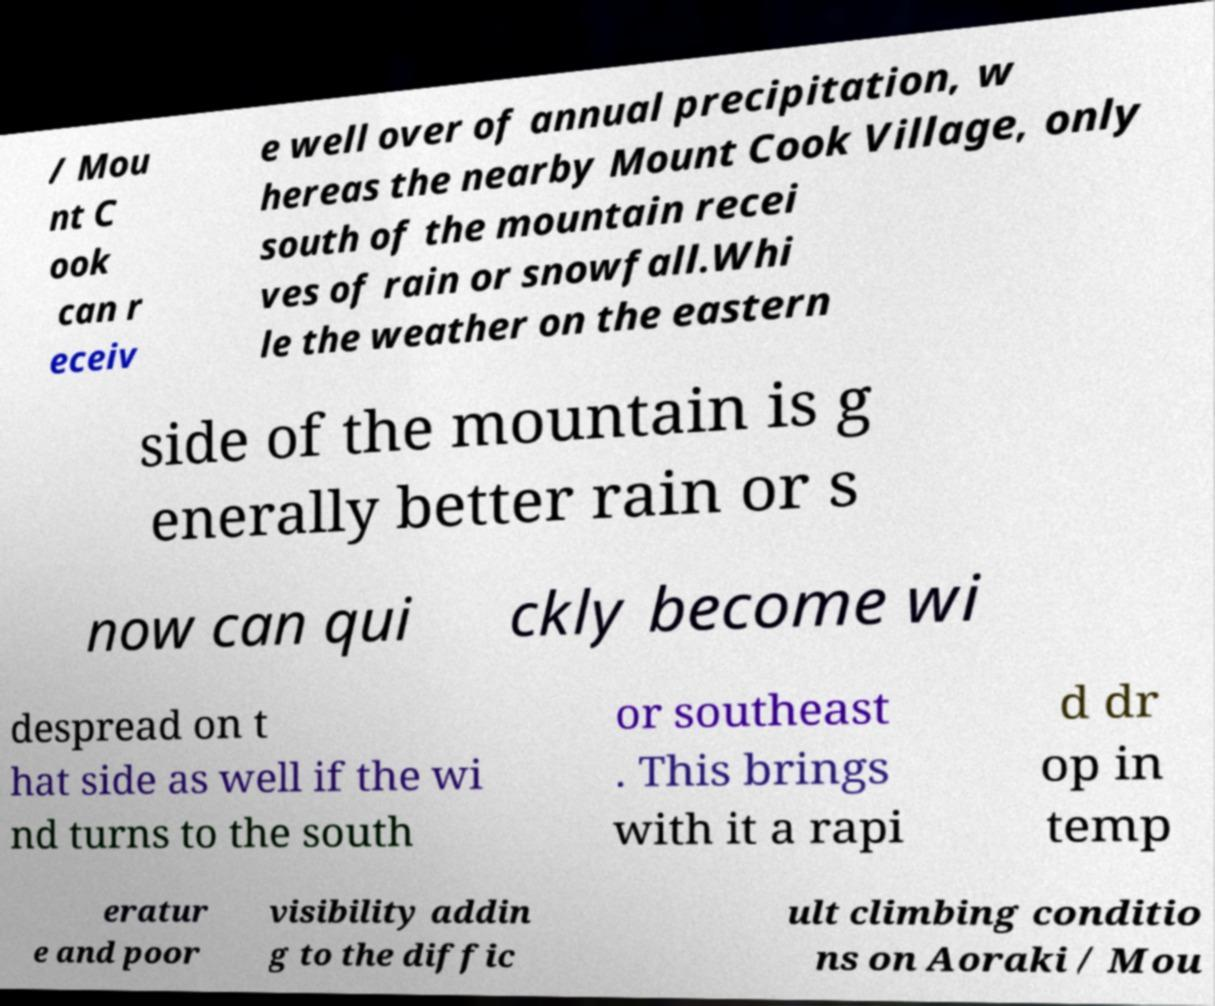For documentation purposes, I need the text within this image transcribed. Could you provide that? / Mou nt C ook can r eceiv e well over of annual precipitation, w hereas the nearby Mount Cook Village, only south of the mountain recei ves of rain or snowfall.Whi le the weather on the eastern side of the mountain is g enerally better rain or s now can qui ckly become wi despread on t hat side as well if the wi nd turns to the south or southeast . This brings with it a rapi d dr op in temp eratur e and poor visibility addin g to the diffic ult climbing conditio ns on Aoraki / Mou 